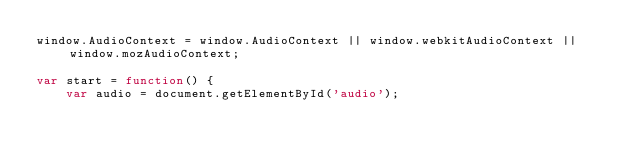<code> <loc_0><loc_0><loc_500><loc_500><_JavaScript_>window.AudioContext = window.AudioContext || window.webkitAudioContext || window.mozAudioContext;

var start = function() {
    var audio = document.getElementById('audio');</code> 